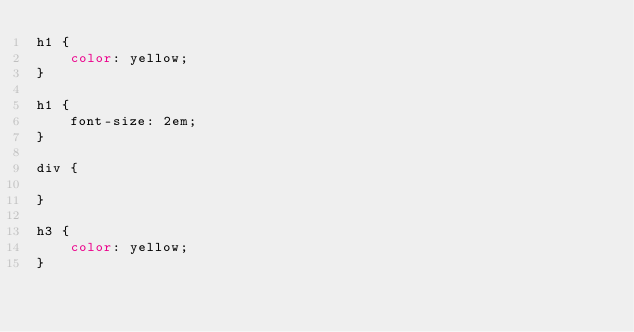Convert code to text. <code><loc_0><loc_0><loc_500><loc_500><_CSS_>h1 {
    color: yellow;
}

h1 {
    font-size: 2em;
}

div {

}

h3 {
    color: yellow;
}
</code> 